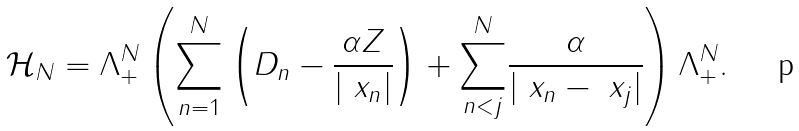<formula> <loc_0><loc_0><loc_500><loc_500>\mathcal { H } _ { N } = \Lambda _ { + } ^ { N } \left ( \underset { n = 1 } { \overset { N } { \sum } } \left ( D _ { n } - \frac { \alpha Z } { | \ x _ { n } | } \right ) + \underset { n < j } { \overset { N } { \sum } } \frac { \alpha } { | \ x _ { n } - \ x _ { j } | } \right ) \Lambda _ { + } ^ { N } .</formula> 